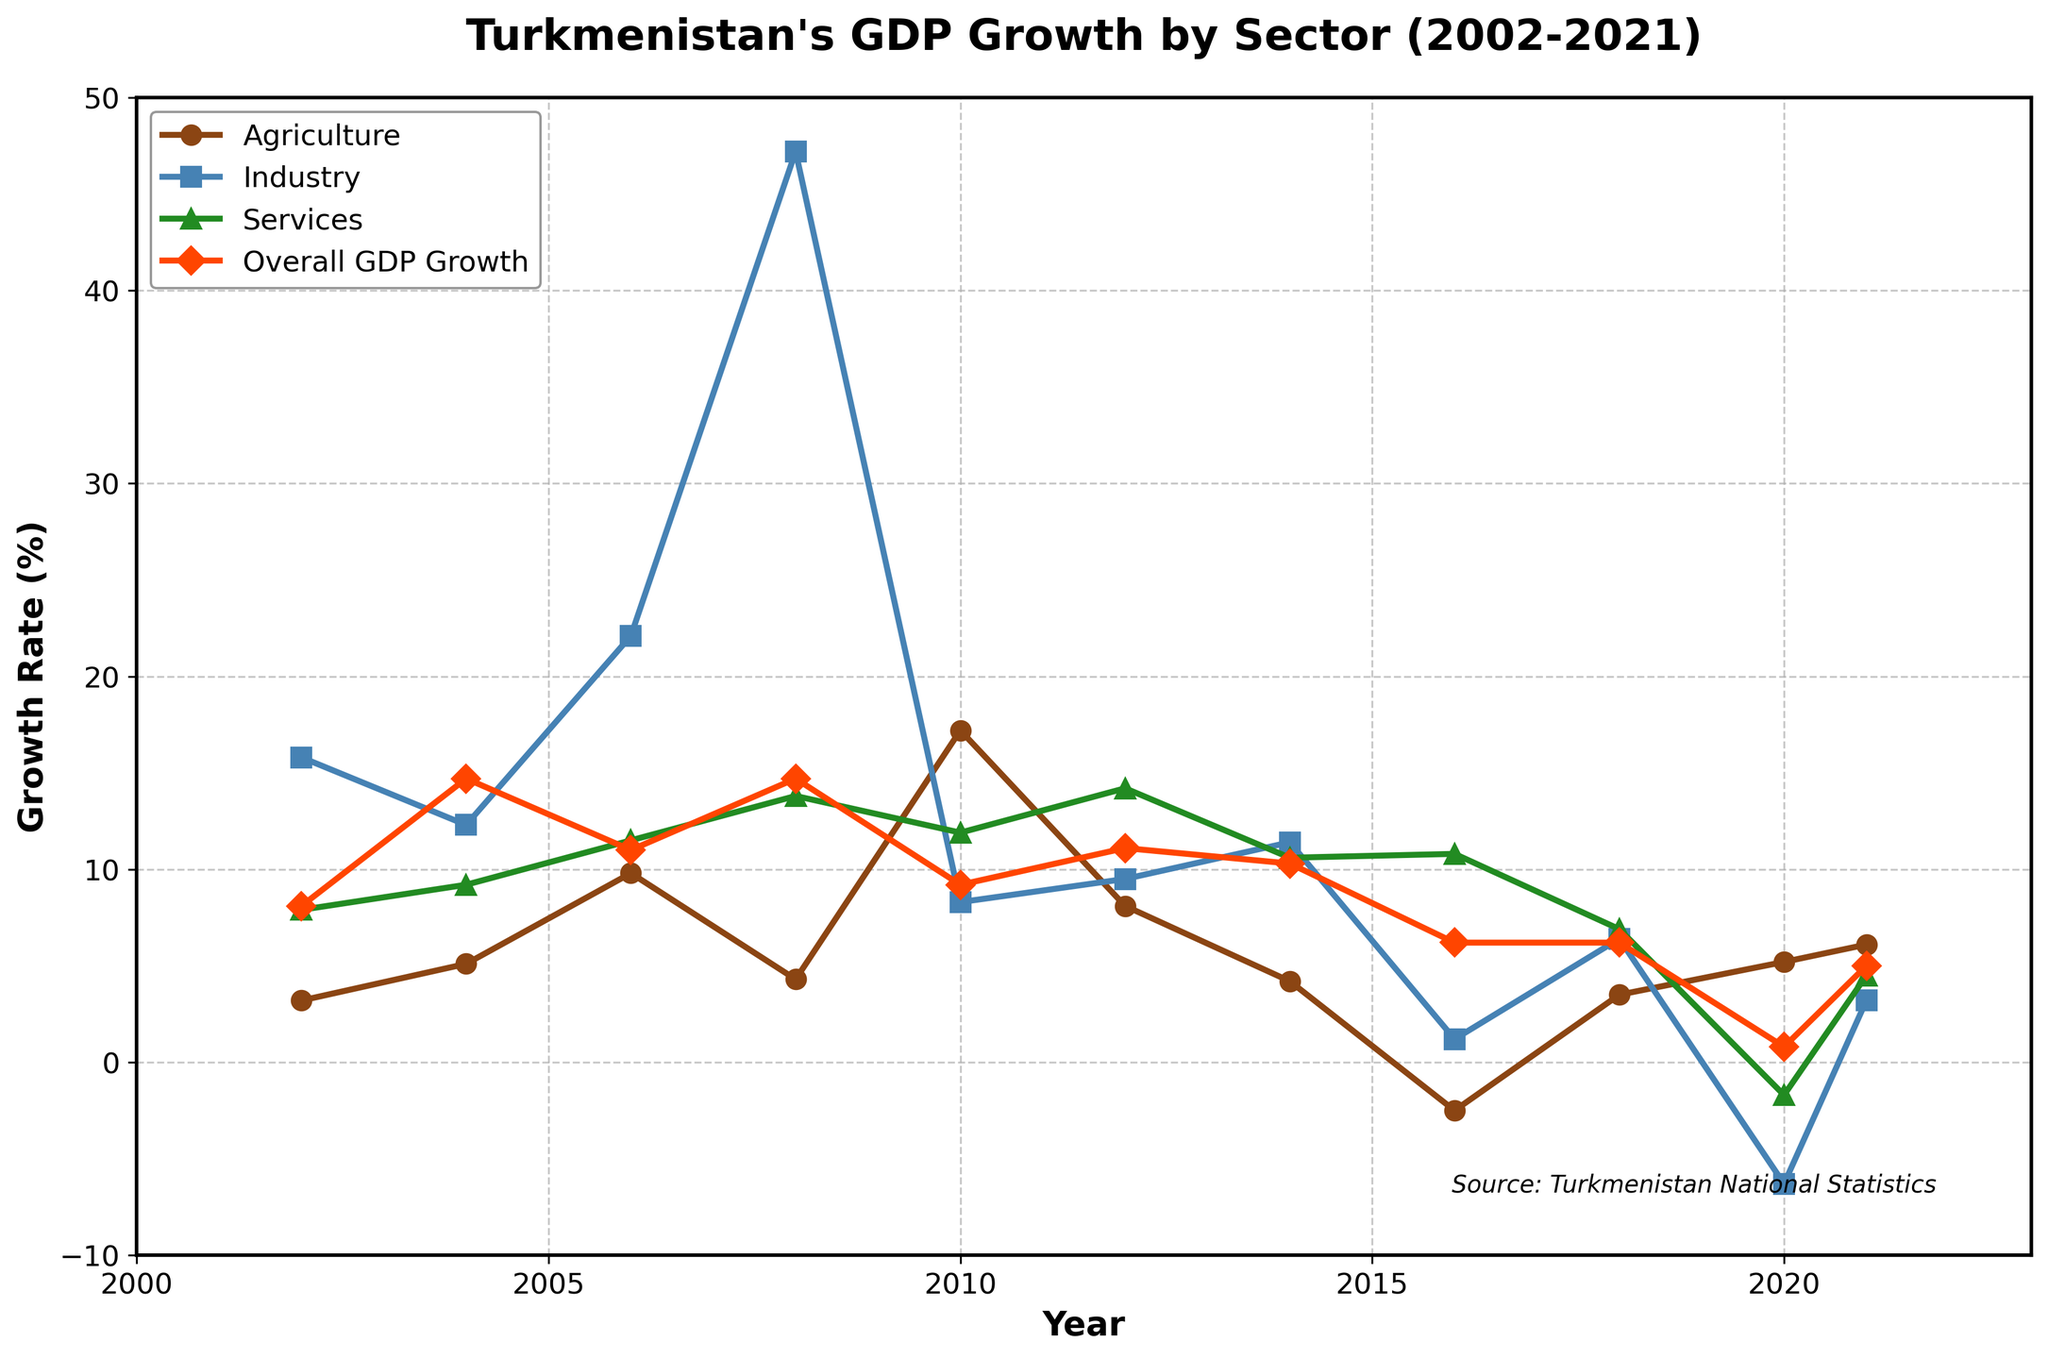What year did Agriculture hit its peak growth rate? Looking at the line for Agriculture, the highest point is around 2010.
Answer: 2010 How did the overall GDP growth rate compare between 2008 and 2020? The overall GDP growth was much higher in 2008 (~14.7%) than in 2020 (~0.8%).
Answer: Higher in 2008 Which sector had a negative growth rate in 2016? The line for Agriculture dips below the 0% growth rate in 2016.
Answer: Agriculture What was the average growth rate of the Services sector from 2010 to 2020? The growth rates for Services in those years are 11.9, 14.2, 10.6, 10.8, 6.9, -1.7. Adding them and dividing by 6: (11.9 + 14.2 + 10.6 + 10.8 + 6.9 - 1.7) / 6 = 8.78%.
Answer: 8.78% Which sector had the highest growth rate in 2008? The line for Industry hits over 40%, the highest among the sectors displayed.
Answer: Industry Between which consecutive years did Industry experience the largest drop in growth rate? The largest drop is observed between 2008 and 2010 where the line for Industry falls dramatically.
Answer: 2008 to 2010 Compare the GDP growth rates of Agriculture and Services in 2006. Which was higher? The growth rate for Agriculture in 2006 was 9.8%, whereas for Services it was 11.5%. Thus, Services was higher.
Answer: Services What colors represent Industry and Services? Industry is represented by a blue line, and Services are represented by a green line.
Answer: Blue and Green How did the overall GDP growth rate change between 2018 and 2021? The overall GDP growth rate was 6.2% in 2018 and decreased to 5% in 2021.
Answer: Decreased What was the difference in growth rate for Industry between 2002 and 2020? In 2002, the Industry growth rate was 15.8%, and in 2020 it was -6.3%. The difference is 15.8 - (-6.3) = 22.1%.
Answer: 22.1% 